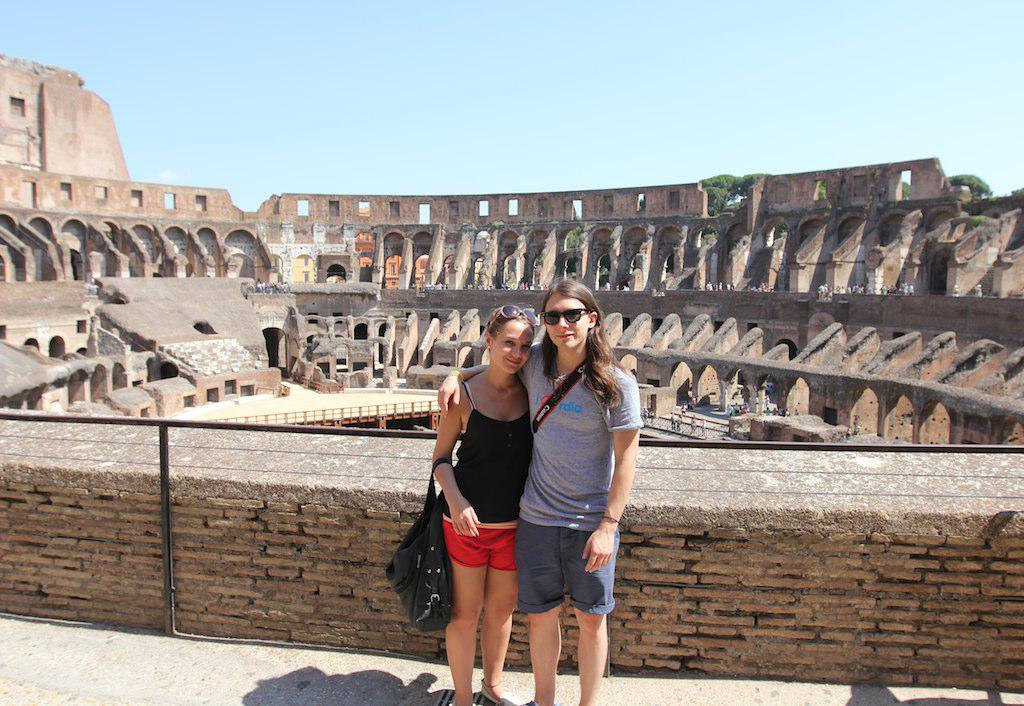How many women are in the image? There are two women in the image. What are the women doing in the image? Both women are standing on the floor and smiling. Can you describe any specific features of one of the women? One of the women is wearing spectacles. What can be seen in the background of the image? There is a monument and the sky visible in the background of the image. Are the women in the image beginner swimmers? There is no indication in the image that the women are swimming or that they are beginner swimmers. Can you see any chickens in the image? There are no chickens present in the image. 